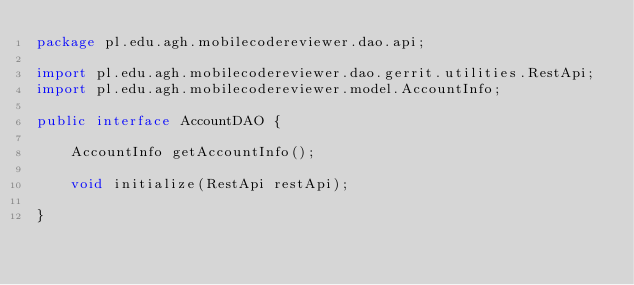<code> <loc_0><loc_0><loc_500><loc_500><_Java_>package pl.edu.agh.mobilecodereviewer.dao.api;

import pl.edu.agh.mobilecodereviewer.dao.gerrit.utilities.RestApi;
import pl.edu.agh.mobilecodereviewer.model.AccountInfo;

public interface AccountDAO {

    AccountInfo getAccountInfo();

    void initialize(RestApi restApi);

}
</code> 